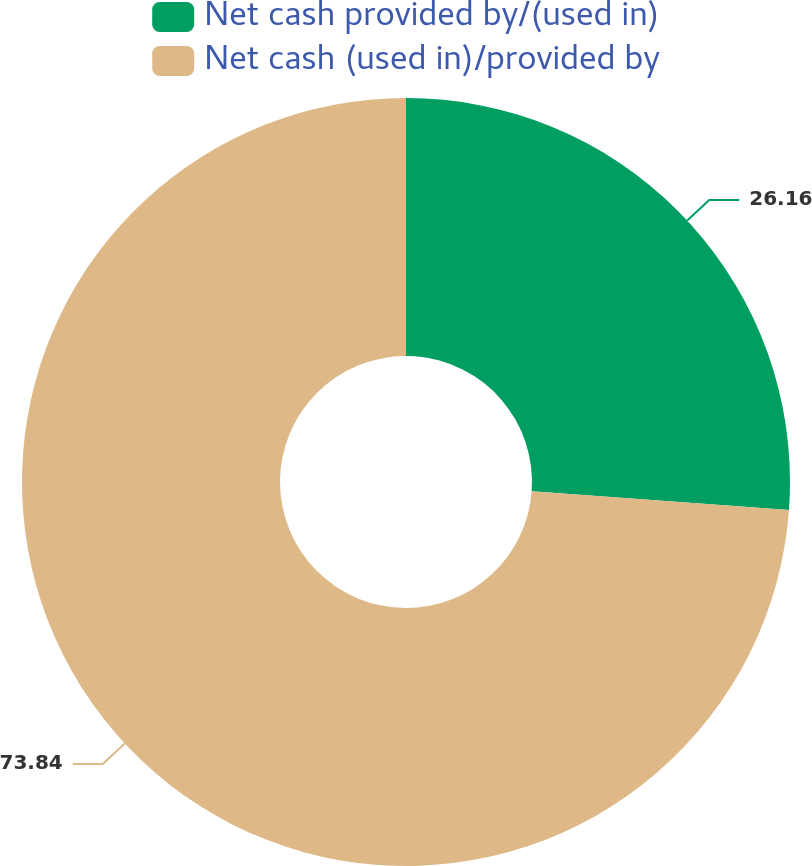<chart> <loc_0><loc_0><loc_500><loc_500><pie_chart><fcel>Net cash provided by/(used in)<fcel>Net cash (used in)/provided by<nl><fcel>26.16%<fcel>73.84%<nl></chart> 